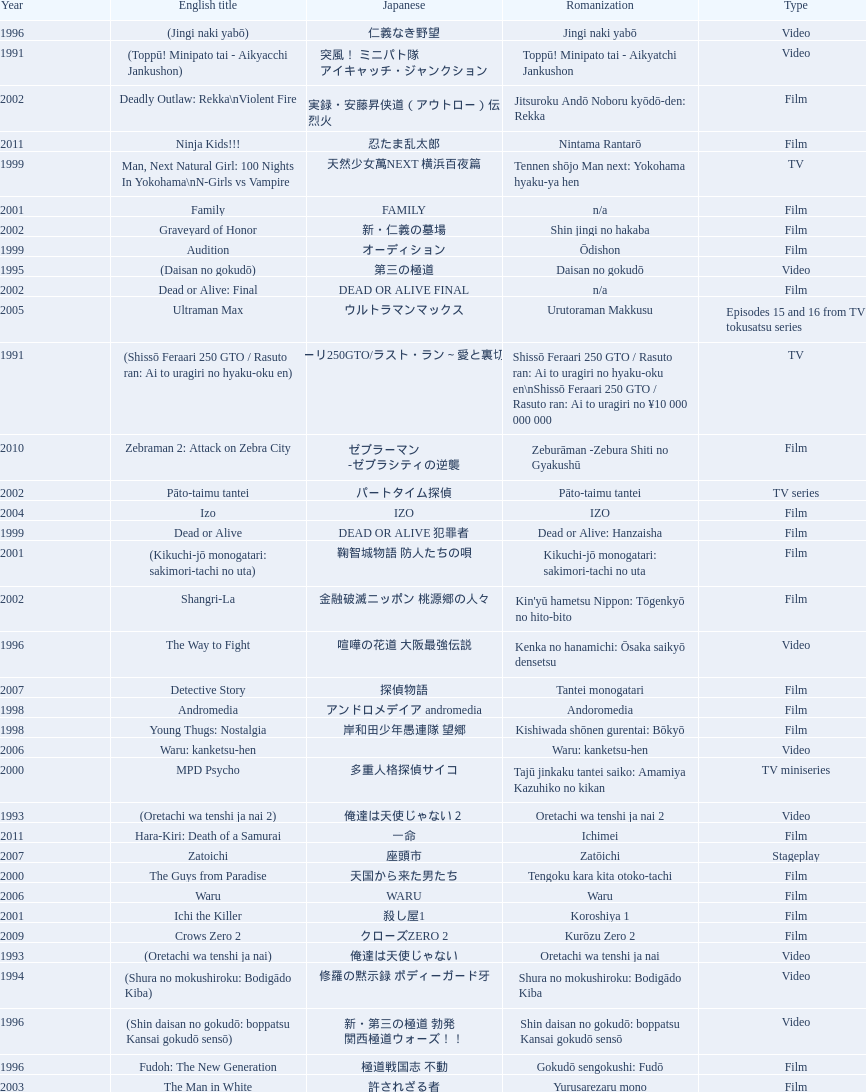How many years is the chart for? 23. 